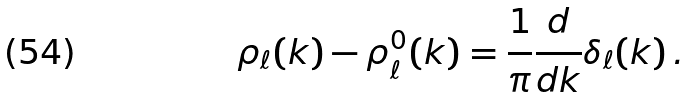<formula> <loc_0><loc_0><loc_500><loc_500>\rho _ { \ell } ( k ) - \rho _ { \ell } ^ { 0 } ( k ) = \frac { 1 } { \pi } \frac { d } { d k } \delta _ { \ell } ( k ) \, .</formula> 